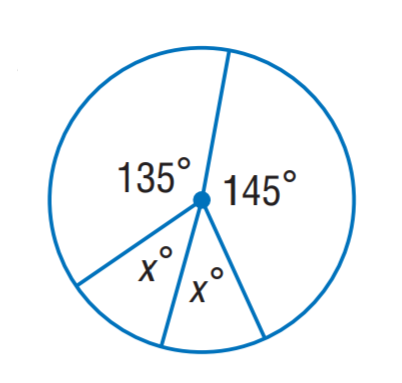Answer the mathemtical geometry problem and directly provide the correct option letter.
Question: Find x.
Choices: A: 10 B: 20 C: 30 D: 40 D 